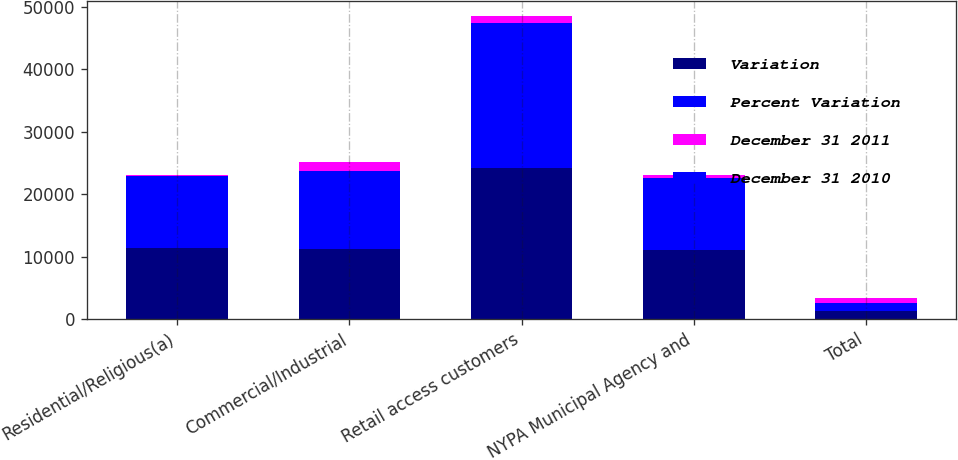<chart> <loc_0><loc_0><loc_500><loc_500><stacked_bar_chart><ecel><fcel>Residential/Religious(a)<fcel>Commercial/Industrial<fcel>Retail access customers<fcel>NYPA Municipal Agency and<fcel>Total<nl><fcel>Variation<fcel>11404<fcel>11148<fcel>24234<fcel>11040<fcel>1273.5<nl><fcel>Percent Variation<fcel>11518<fcel>12559<fcel>23098<fcel>11518<fcel>1273.5<nl><fcel>December 31 2011<fcel>114<fcel>1411<fcel>1136<fcel>478<fcel>867<nl><fcel>December 31 2010<fcel>1<fcel>11.2<fcel>4.9<fcel>4.2<fcel>1.5<nl></chart> 